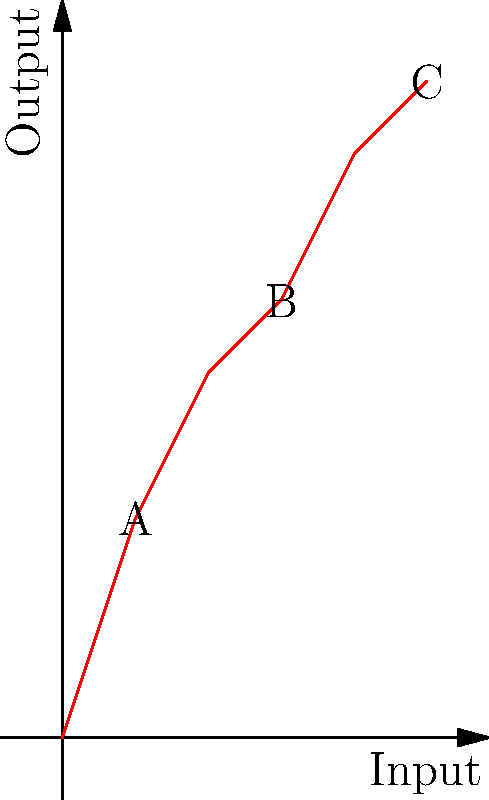In a manufacturing process, the input-output relationship is represented by the graph above. If the process efficiency is defined as the ratio of output increase to input increase between two points, what is the efficiency of the process between points A and C? To determine the efficiency of the manufacturing process between points A and C, we need to calculate the ratio of output increase to input increase. Let's break it down step-by-step:

1. Identify the coordinates of points A and C:
   Point A: (1, 3)
   Point C: (5, 9)

2. Calculate the input increase:
   $\Delta \text{Input} = x_C - x_A = 5 - 1 = 4$

3. Calculate the output increase:
   $\Delta \text{Output} = y_C - y_A = 9 - 3 = 6$

4. Calculate the efficiency using the formula:
   $\text{Efficiency} = \frac{\Delta \text{Output}}{\Delta \text{Input}} = \frac{6}{4} = 1.5$

5. Interpret the result:
   An efficiency of 1.5 means that for every unit increase in input, the output increases by 1.5 units on average between points A and C.

This efficiency calculation is particularly relevant in vocational education, as it demonstrates how to analyze and interpret production data, which is a valuable skill in many technical and manufacturing fields.
Answer: 1.5 